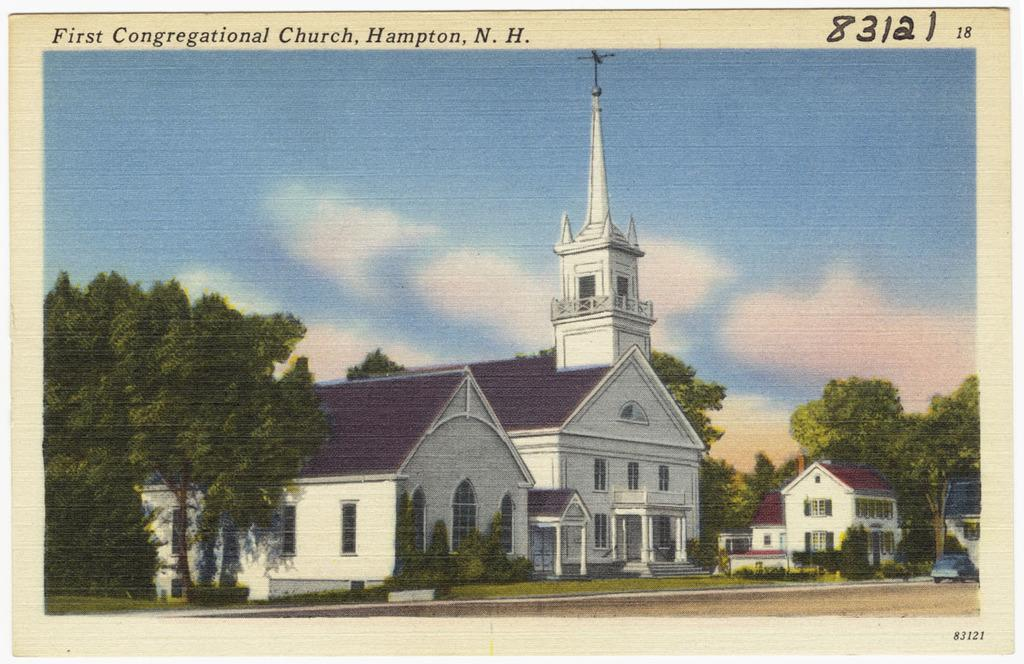What type of artwork is depicted in the image? The image is a painting. What can be seen on the right side of the painting? There are buildings and trees on the right side of the image. What is present on the left side of the painting? There are trees on the left side of the image. What is visible in the background of the painting? There is a sky visible in the background of the image, and clouds are present. How many brothers are depicted in the painting? There are no people, let alone brothers, depicted in the painting; it features buildings, trees, and a sky. What type of furniture can be seen in the painting? There is no furniture present in the painting; it features buildings, trees, and a sky. 